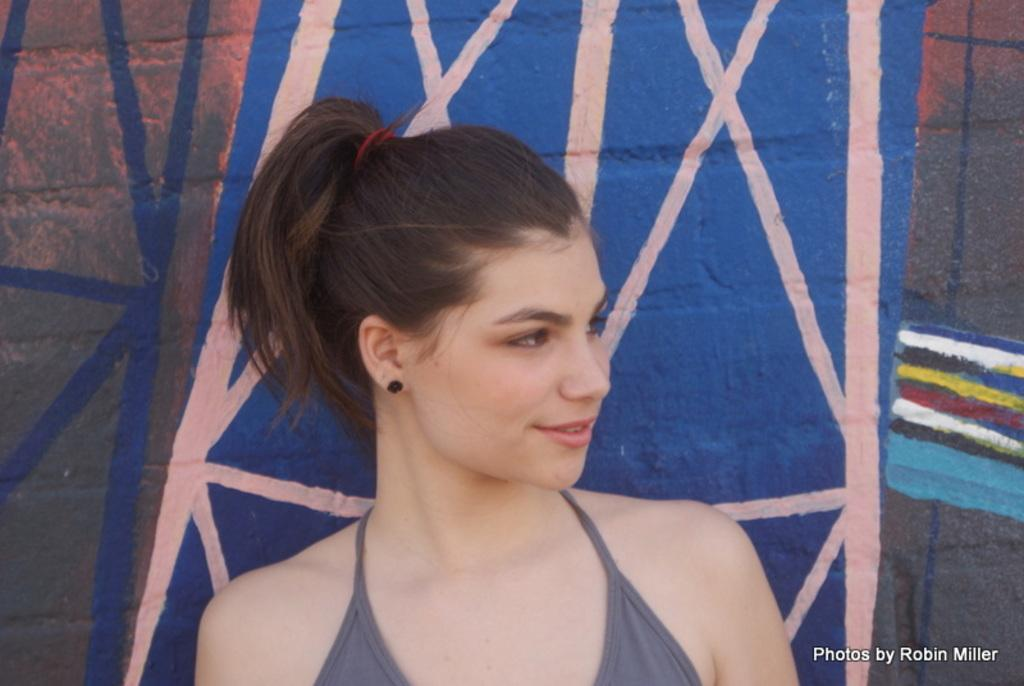Who is present in the image? There is a woman in the image. What can be seen on the wall in the image? There is a painting on the wall in the image. Can you describe any additional features of the image? Yes, there is a watermark at the bottom of the image. What type of cheese is being offered in the image? There is no cheese present in the image. How many cakes are visible in the image? There are no cakes visible in the image. 